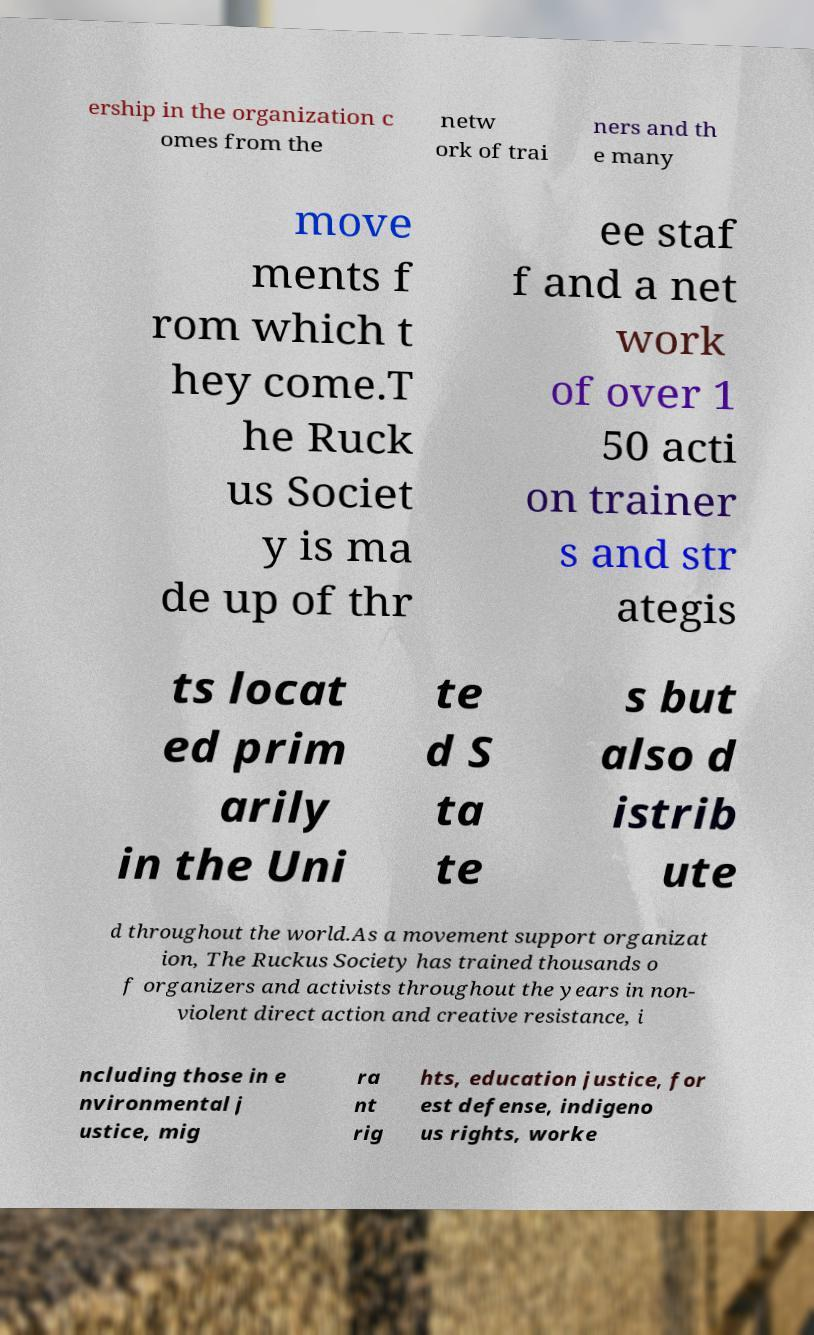Could you extract and type out the text from this image? ership in the organization c omes from the netw ork of trai ners and th e many move ments f rom which t hey come.T he Ruck us Societ y is ma de up of thr ee staf f and a net work of over 1 50 acti on trainer s and str ategis ts locat ed prim arily in the Uni te d S ta te s but also d istrib ute d throughout the world.As a movement support organizat ion, The Ruckus Society has trained thousands o f organizers and activists throughout the years in non- violent direct action and creative resistance, i ncluding those in e nvironmental j ustice, mig ra nt rig hts, education justice, for est defense, indigeno us rights, worke 